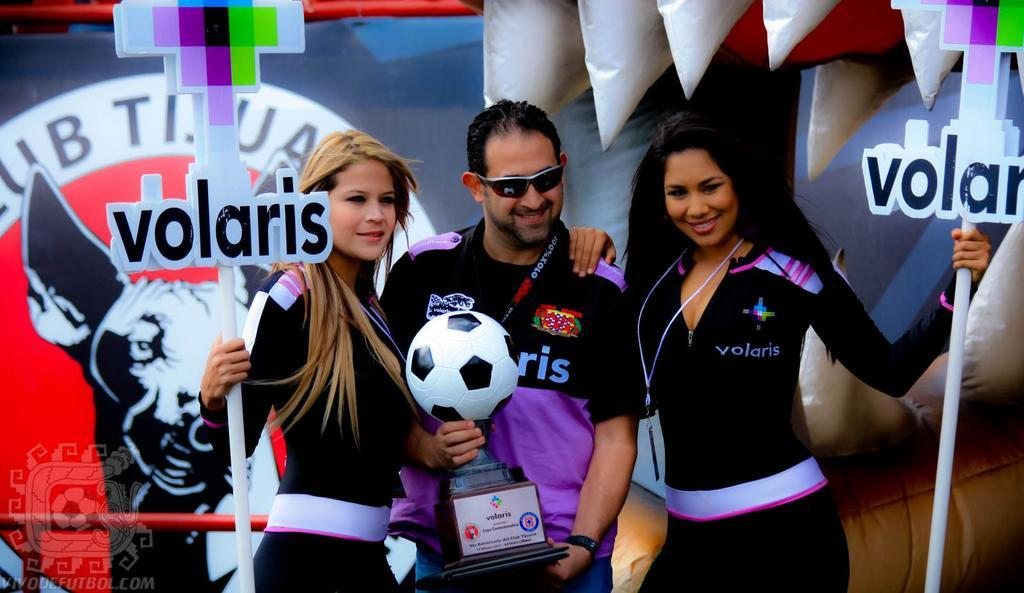How many people are present in the image? There are three people in the image, including a woman standing beside a man and another woman standing on the right side. What is the context of the image? The image is related to a football cup. What type of meat is being served on the table in the image? There is no table or meat present in the image; it features three people and is related to a football cup. 